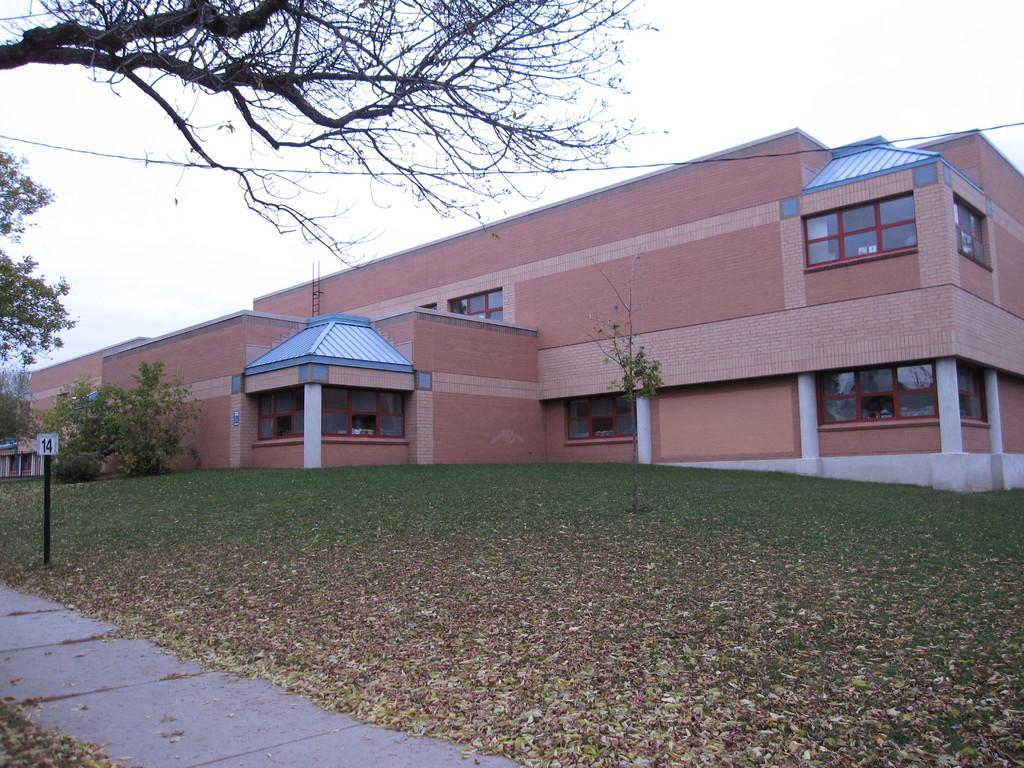What type of living organisms can be seen in the image? Plants can be seen in the image. What color are the plants in the image? The plants are green. What type of structure is present in the image? There is a building in the image. What color is the building in the image? The building is brown. What feature can be seen on the building? There are glass windows on the building. What is visible in the background of the image? The sky is visible in the background of the image. What color is the sky in the image? The sky is white in color. What scent can be detected from the plants in the image? There is no information about the scent of the plants in the image, as smell is not a sense that can be captured in a photograph. 